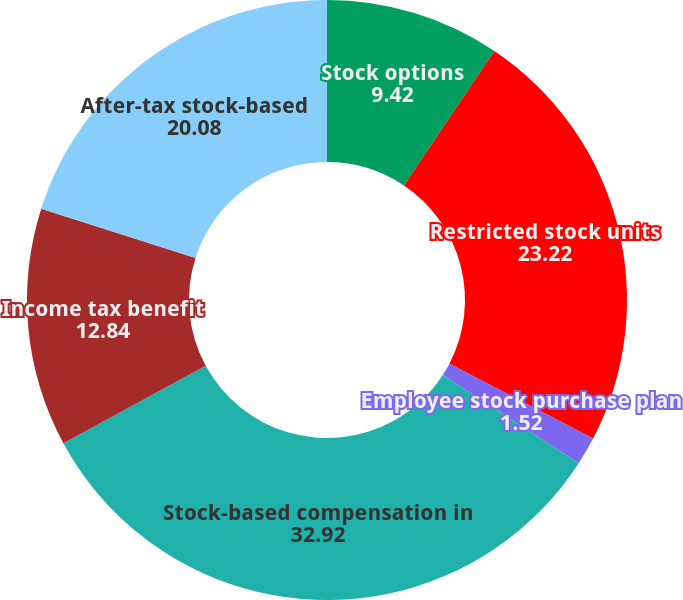<chart> <loc_0><loc_0><loc_500><loc_500><pie_chart><fcel>Stock options<fcel>Restricted stock units<fcel>Employee stock purchase plan<fcel>Stock-based compensation in<fcel>Income tax benefit<fcel>After-tax stock-based<nl><fcel>9.42%<fcel>23.22%<fcel>1.52%<fcel>32.92%<fcel>12.84%<fcel>20.08%<nl></chart> 